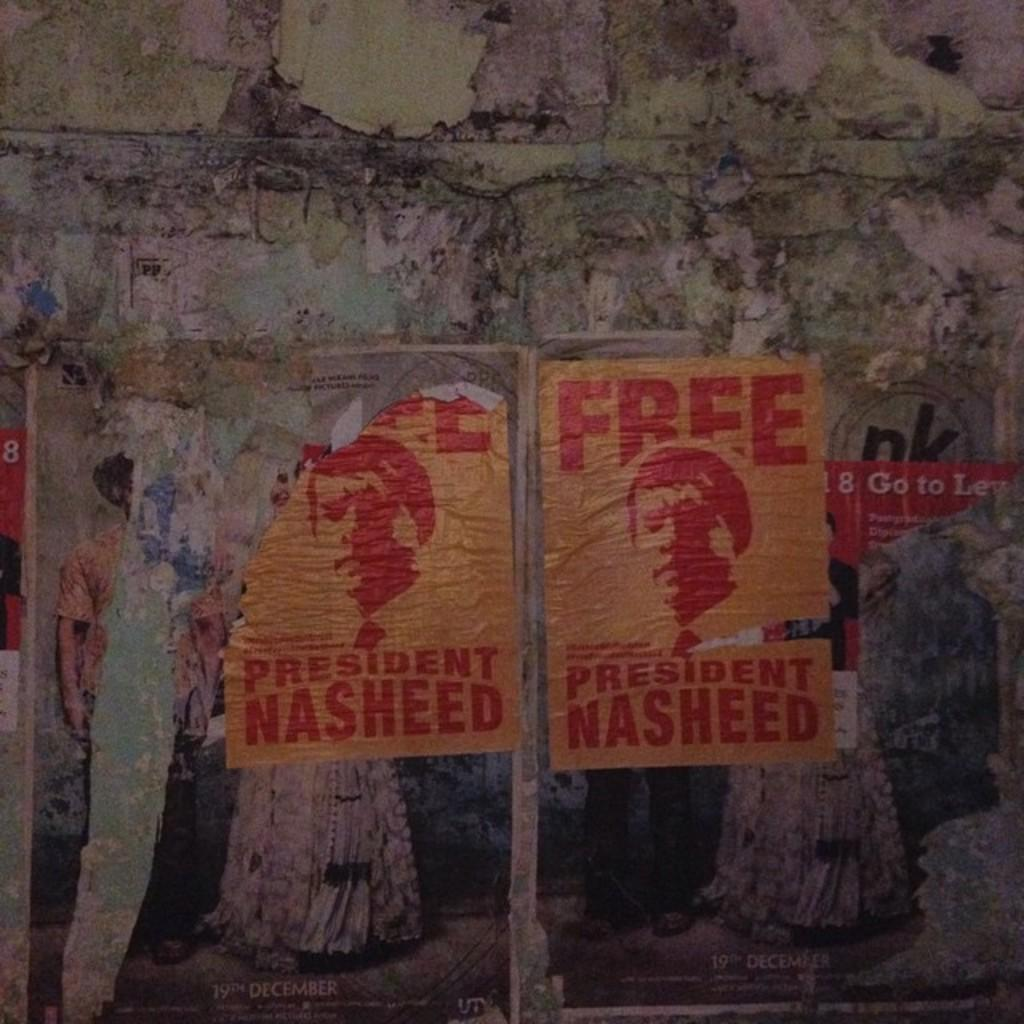<image>
Render a clear and concise summary of the photo. Torn posters on a wall show the face of a man and urge the freeing of President Nasheed in red lettering on a yellow background 